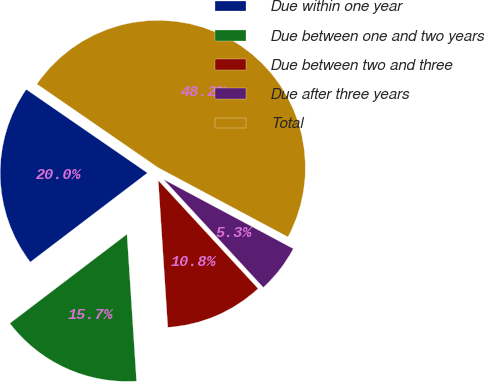Convert chart. <chart><loc_0><loc_0><loc_500><loc_500><pie_chart><fcel>Due within one year<fcel>Due between one and two years<fcel>Due between two and three<fcel>Due after three years<fcel>Total<nl><fcel>19.96%<fcel>15.68%<fcel>10.83%<fcel>5.33%<fcel>48.2%<nl></chart> 